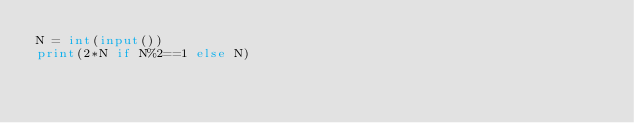Convert code to text. <code><loc_0><loc_0><loc_500><loc_500><_Python_>N = int(input())
print(2*N if N%2==1 else N)</code> 